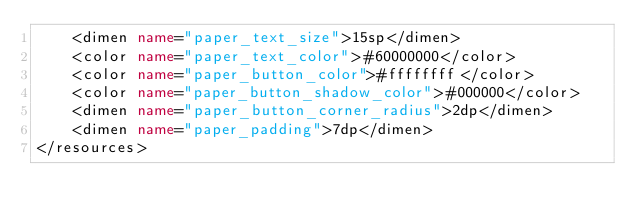<code> <loc_0><loc_0><loc_500><loc_500><_XML_>    <dimen name="paper_text_size">15sp</dimen>
    <color name="paper_text_color">#60000000</color>
    <color name="paper_button_color">#ffffffff</color>
    <color name="paper_button_shadow_color">#000000</color>
    <dimen name="paper_button_corner_radius">2dp</dimen>
    <dimen name="paper_padding">7dp</dimen>
</resources></code> 